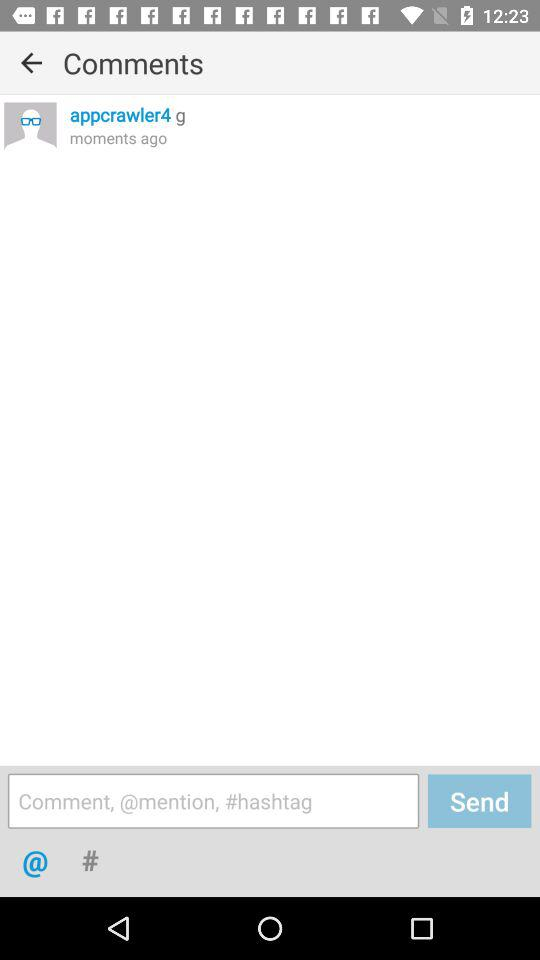How long ago was the comment updated? The comment was updated moments ago. 